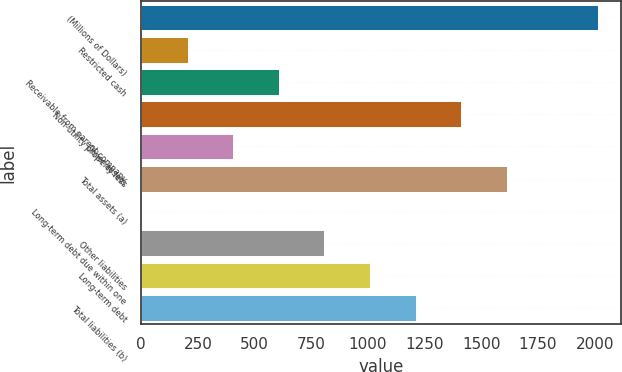Convert chart to OTSL. <chart><loc_0><loc_0><loc_500><loc_500><bar_chart><fcel>(Millions of Dollars)<fcel>Restricted cash<fcel>Receivable from parent company<fcel>Non-utility property less<fcel>Other assets<fcel>Total assets (a)<fcel>Long-term debt due within one<fcel>Other liabilities<fcel>Long-term debt<fcel>Total liabilities (b)<nl><fcel>2016<fcel>204.3<fcel>606.9<fcel>1412.1<fcel>405.6<fcel>1613.4<fcel>3<fcel>808.2<fcel>1009.5<fcel>1210.8<nl></chart> 